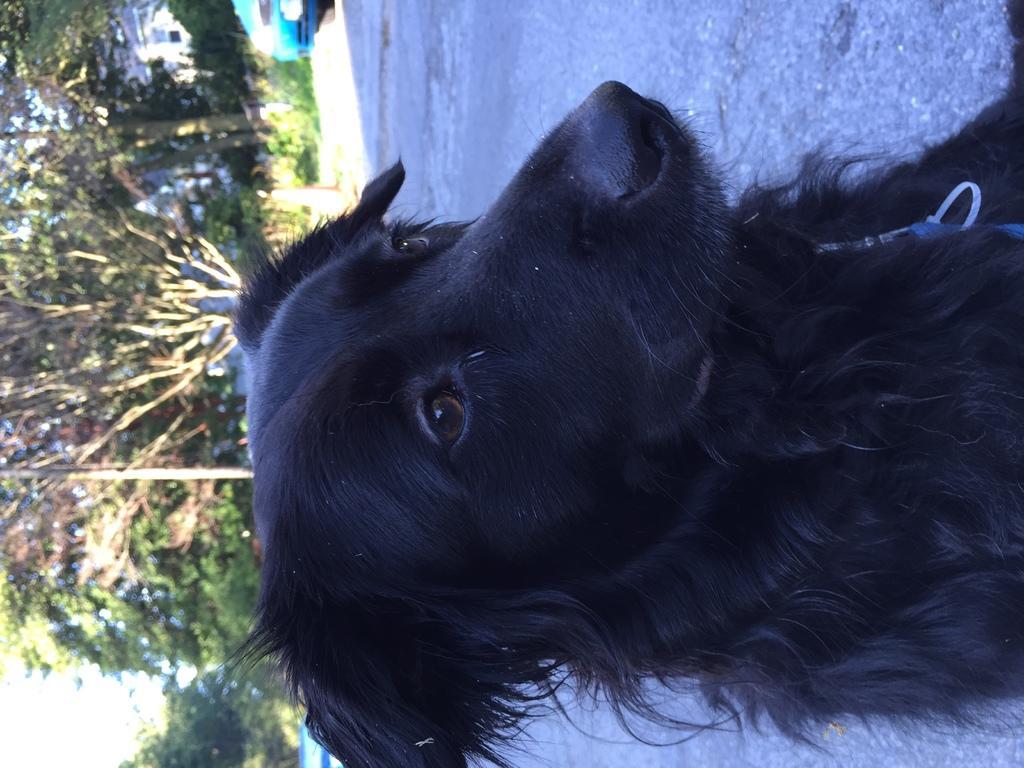Please provide a concise description of this image. In this picture we can see a dog on the road and in the background we can see a vehicle, traffic cone, pole and trees. 